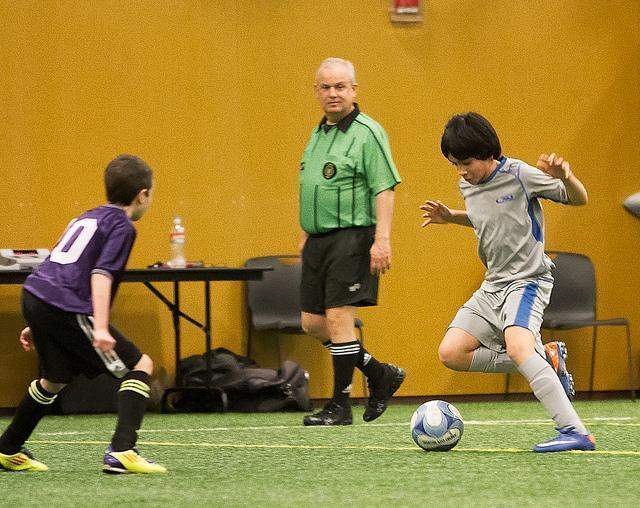How many chairs are visible?
Give a very brief answer. 2. How many people are there?
Give a very brief answer. 3. How many sliced bananas are in the photo?
Give a very brief answer. 0. 